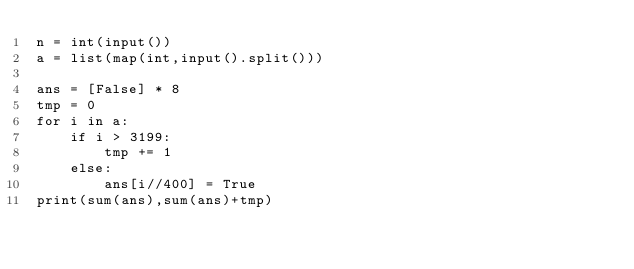<code> <loc_0><loc_0><loc_500><loc_500><_Python_>n = int(input())
a = list(map(int,input().split()))

ans = [False] * 8
tmp = 0
for i in a:
    if i > 3199:
        tmp += 1
    else:
        ans[i//400] = True
print(sum(ans),sum(ans)+tmp)</code> 